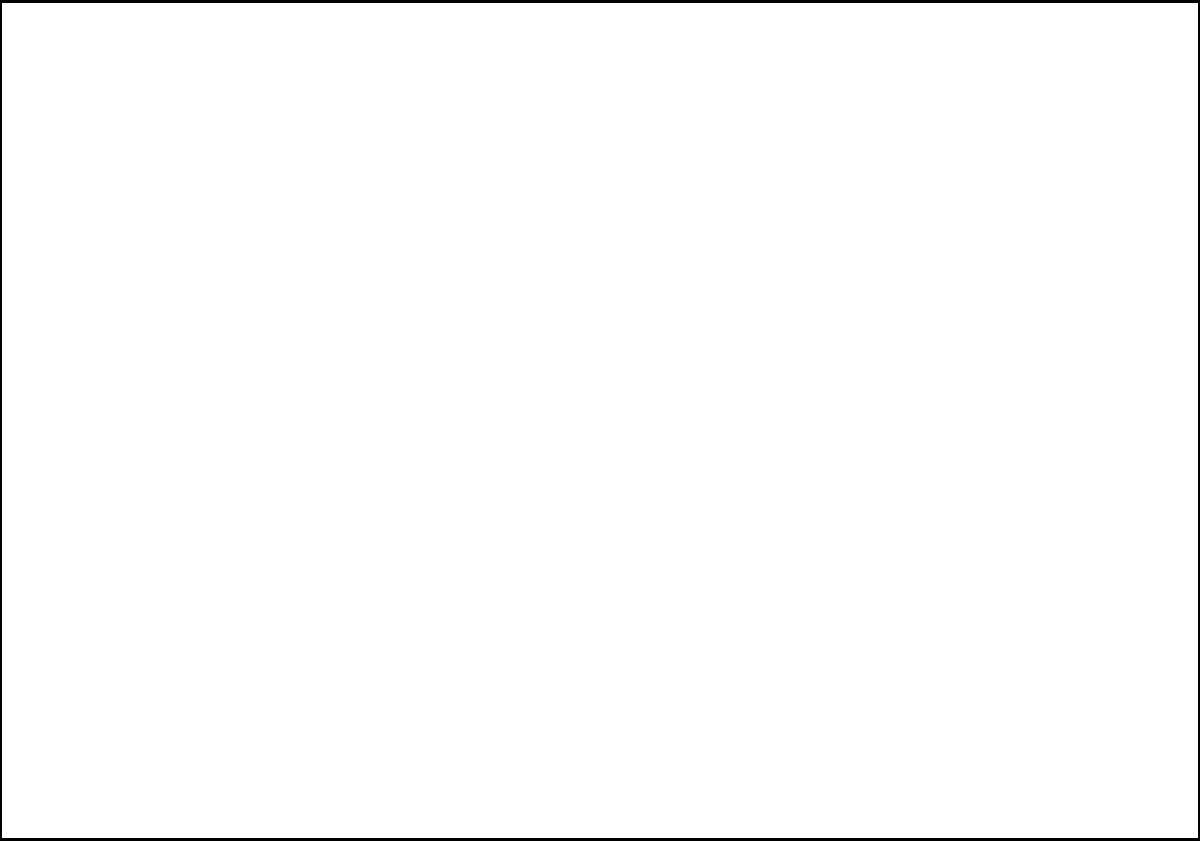In the given image with gridlines, which composition technique is best exemplified by the placement of the model, particularly considering points A and B? To determine the composition technique used in this fashion photograph, let's analyze the image step-by-step:

1. The image is divided into a 10x7 grid, which is reminiscent of the rule of thirds grid (a 3x3 grid).

2. The model's silhouette (represented by the red curve) is not centered in the frame. Instead, it spans from the left third to the right third of the image.

3. Point A is located near the left third vertical line and the top third horizontal line intersection.

4. Point B is positioned close to the right third vertical line and the upper third horizontal line.

5. The placement of these key points (A and B) near the intersections of the third lines is a clear indication of the rule of thirds being applied.

6. The rule of thirds suggests placing important elements of the composition along these third lines or at their intersections to create a more balanced and interesting image.

7. In fashion photography, this technique can draw attention to specific parts of the garment or the model's pose, creating a more dynamic and engaging composition.

Given this analysis, the composition technique best exemplified by the placement of the model, particularly considering points A and B, is the rule of thirds.
Answer: Rule of thirds 